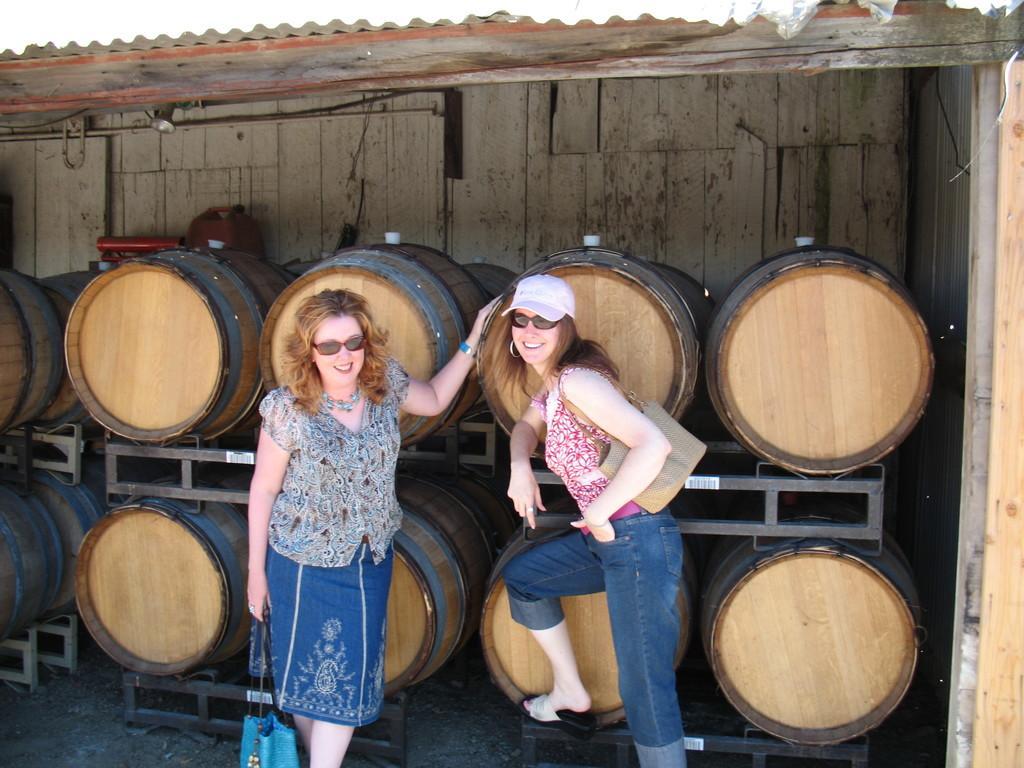Please provide a concise description of this image. Here in this picture we can see two women standing over a place and both of them are smiling and wearing goggles on them and carrying hand bags with them and the woman on the right side is wearing a cap on her and behind them we can see barrels present in the stands over there and above them we can see a roof covered over there. 